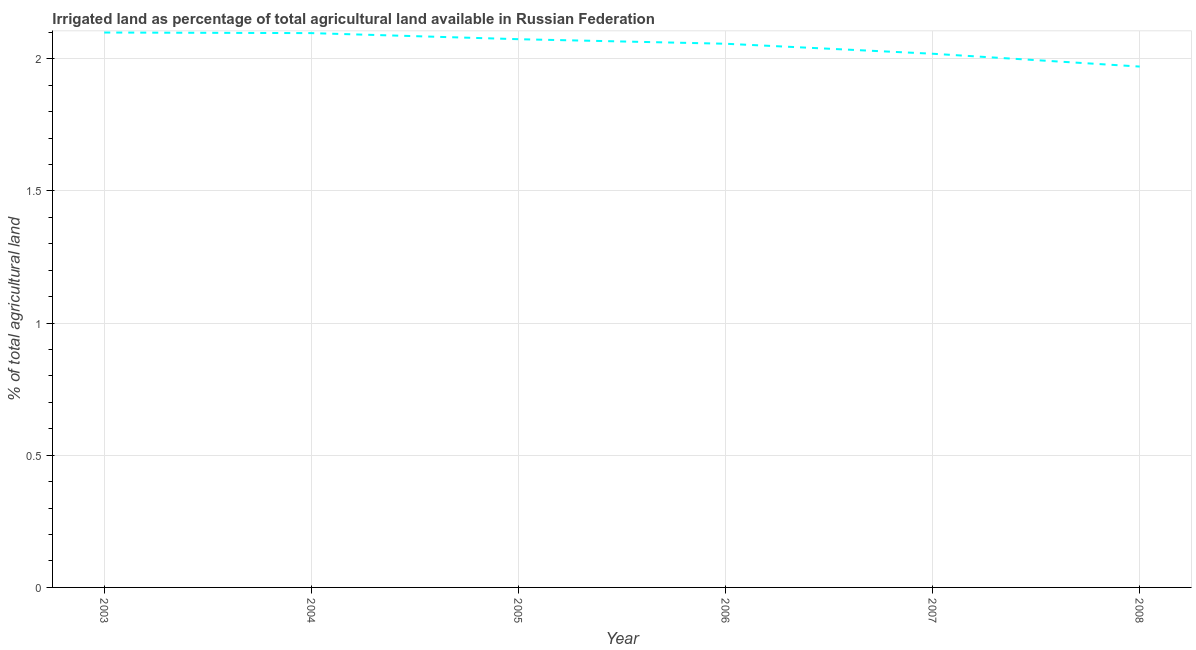What is the percentage of agricultural irrigated land in 2008?
Your answer should be very brief. 1.97. Across all years, what is the maximum percentage of agricultural irrigated land?
Provide a succinct answer. 2.1. Across all years, what is the minimum percentage of agricultural irrigated land?
Provide a short and direct response. 1.97. In which year was the percentage of agricultural irrigated land maximum?
Ensure brevity in your answer.  2003. In which year was the percentage of agricultural irrigated land minimum?
Give a very brief answer. 2008. What is the sum of the percentage of agricultural irrigated land?
Offer a terse response. 12.32. What is the difference between the percentage of agricultural irrigated land in 2004 and 2006?
Offer a very short reply. 0.04. What is the average percentage of agricultural irrigated land per year?
Provide a succinct answer. 2.05. What is the median percentage of agricultural irrigated land?
Ensure brevity in your answer.  2.07. What is the ratio of the percentage of agricultural irrigated land in 2003 to that in 2006?
Offer a very short reply. 1.02. What is the difference between the highest and the second highest percentage of agricultural irrigated land?
Keep it short and to the point. 0. What is the difference between the highest and the lowest percentage of agricultural irrigated land?
Provide a succinct answer. 0.13. In how many years, is the percentage of agricultural irrigated land greater than the average percentage of agricultural irrigated land taken over all years?
Provide a short and direct response. 4. How many lines are there?
Give a very brief answer. 1. Does the graph contain any zero values?
Make the answer very short. No. What is the title of the graph?
Your answer should be compact. Irrigated land as percentage of total agricultural land available in Russian Federation. What is the label or title of the X-axis?
Your answer should be compact. Year. What is the label or title of the Y-axis?
Offer a terse response. % of total agricultural land. What is the % of total agricultural land of 2003?
Make the answer very short. 2.1. What is the % of total agricultural land of 2004?
Your answer should be very brief. 2.1. What is the % of total agricultural land of 2005?
Your answer should be very brief. 2.07. What is the % of total agricultural land of 2006?
Provide a short and direct response. 2.06. What is the % of total agricultural land in 2007?
Provide a succinct answer. 2.02. What is the % of total agricultural land of 2008?
Keep it short and to the point. 1.97. What is the difference between the % of total agricultural land in 2003 and 2004?
Ensure brevity in your answer.  0. What is the difference between the % of total agricultural land in 2003 and 2005?
Make the answer very short. 0.03. What is the difference between the % of total agricultural land in 2003 and 2006?
Your answer should be very brief. 0.04. What is the difference between the % of total agricultural land in 2003 and 2007?
Your answer should be compact. 0.08. What is the difference between the % of total agricultural land in 2003 and 2008?
Your response must be concise. 0.13. What is the difference between the % of total agricultural land in 2004 and 2005?
Keep it short and to the point. 0.02. What is the difference between the % of total agricultural land in 2004 and 2006?
Provide a succinct answer. 0.04. What is the difference between the % of total agricultural land in 2004 and 2007?
Your answer should be compact. 0.08. What is the difference between the % of total agricultural land in 2004 and 2008?
Provide a short and direct response. 0.13. What is the difference between the % of total agricultural land in 2005 and 2006?
Give a very brief answer. 0.02. What is the difference between the % of total agricultural land in 2005 and 2007?
Provide a short and direct response. 0.06. What is the difference between the % of total agricultural land in 2005 and 2008?
Provide a short and direct response. 0.1. What is the difference between the % of total agricultural land in 2006 and 2007?
Your answer should be compact. 0.04. What is the difference between the % of total agricultural land in 2006 and 2008?
Your answer should be compact. 0.09. What is the difference between the % of total agricultural land in 2007 and 2008?
Your response must be concise. 0.05. What is the ratio of the % of total agricultural land in 2003 to that in 2005?
Give a very brief answer. 1.01. What is the ratio of the % of total agricultural land in 2003 to that in 2007?
Offer a terse response. 1.04. What is the ratio of the % of total agricultural land in 2003 to that in 2008?
Your answer should be very brief. 1.06. What is the ratio of the % of total agricultural land in 2004 to that in 2006?
Keep it short and to the point. 1.02. What is the ratio of the % of total agricultural land in 2004 to that in 2007?
Keep it short and to the point. 1.04. What is the ratio of the % of total agricultural land in 2004 to that in 2008?
Your response must be concise. 1.06. What is the ratio of the % of total agricultural land in 2005 to that in 2006?
Provide a succinct answer. 1.01. What is the ratio of the % of total agricultural land in 2005 to that in 2008?
Provide a short and direct response. 1.05. What is the ratio of the % of total agricultural land in 2006 to that in 2008?
Keep it short and to the point. 1.04. What is the ratio of the % of total agricultural land in 2007 to that in 2008?
Keep it short and to the point. 1.02. 